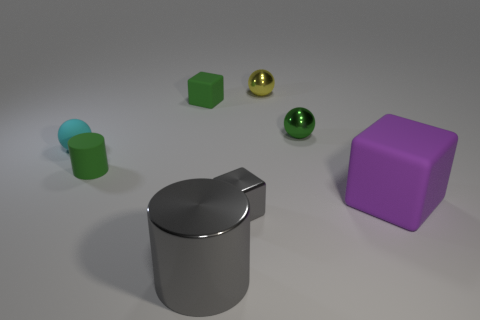Add 1 tiny gray things. How many objects exist? 9 Subtract all spheres. How many objects are left? 5 Add 5 small red cylinders. How many small red cylinders exist? 5 Subtract 1 gray cylinders. How many objects are left? 7 Subtract all big brown rubber spheres. Subtract all yellow things. How many objects are left? 7 Add 1 large metal cylinders. How many large metal cylinders are left? 2 